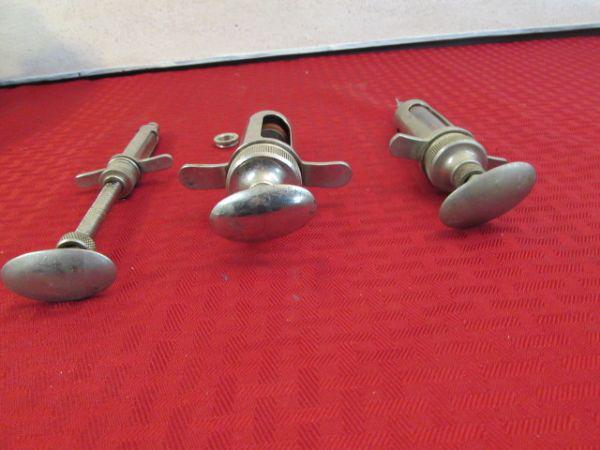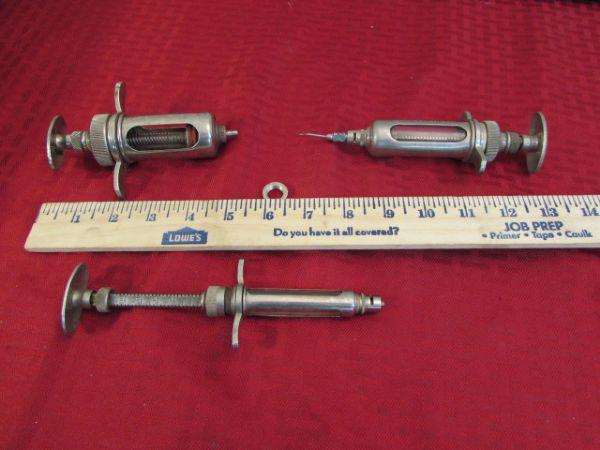The first image is the image on the left, the second image is the image on the right. Given the left and right images, does the statement "At least one image includes an all-metal syringe displayed on a red surface." hold true? Answer yes or no. Yes. The first image is the image on the left, the second image is the image on the right. For the images displayed, is the sentence "At least one syringe in the image on the left has a pink tip." factually correct? Answer yes or no. No. 